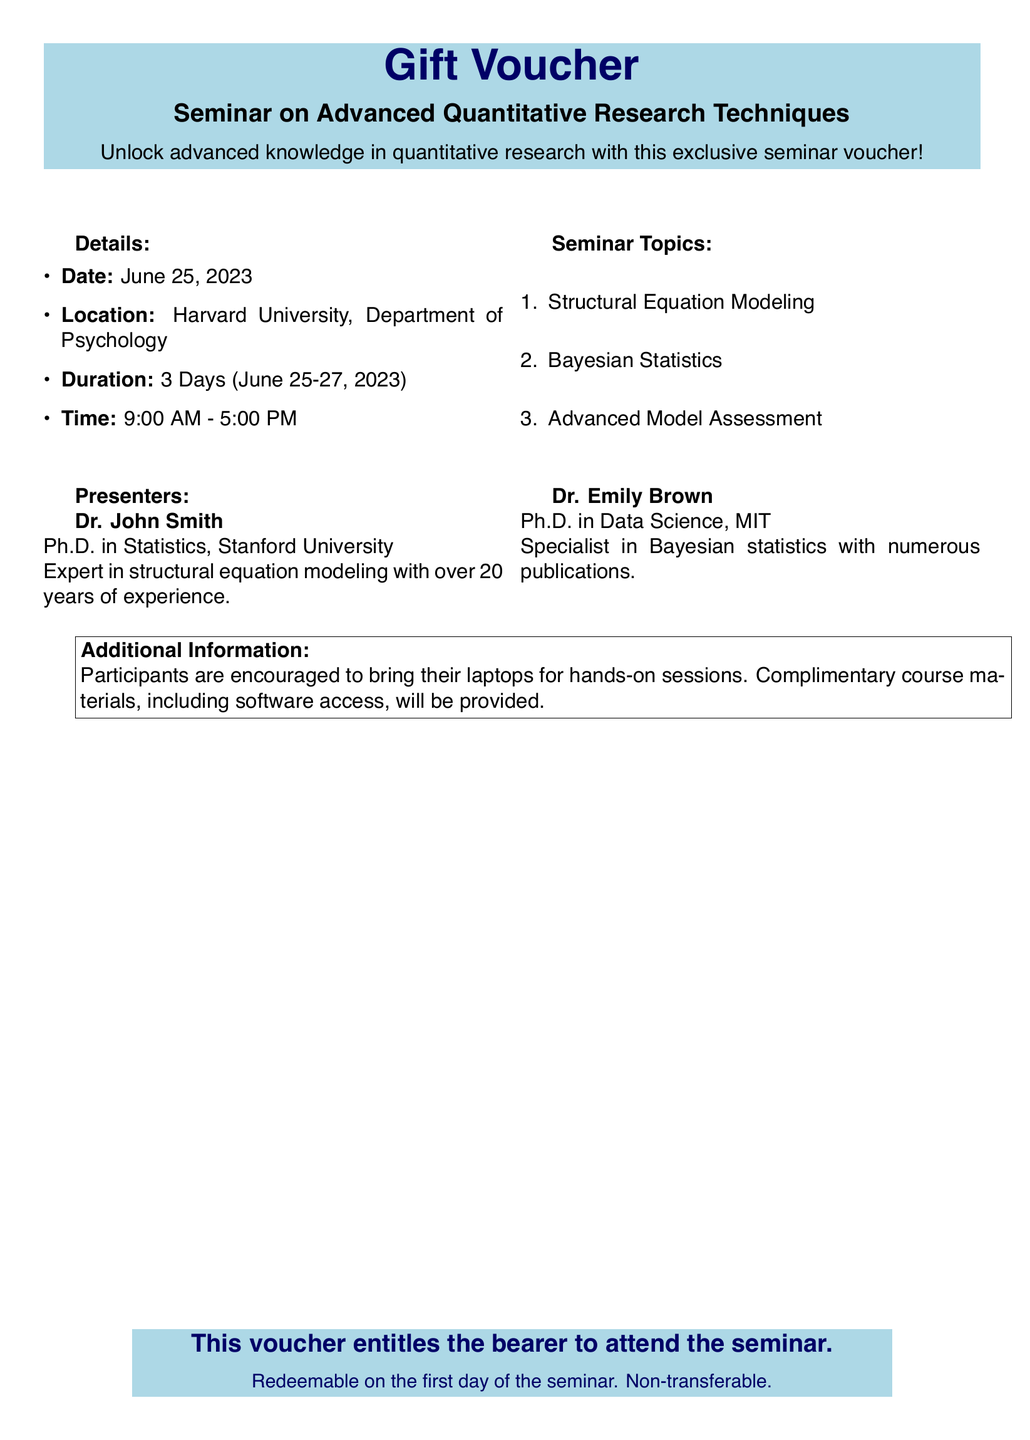What is the date of the seminar? The date of the seminar is explicitly stated in the details section of the document.
Answer: June 25, 2023 Where is the seminar located? The location of the seminar is mentioned directly in the details section of the document.
Answer: Harvard University, Department of Psychology How many days does the seminar last? The duration of the seminar is provided in the details section, indicating the total number of days.
Answer: 3 Days Who is one of the presenters? The document lists the presenters with their names in the presenters section, allowing us to identify one.
Answer: Dr. John Smith What is one of the seminar topics? The seminar topics are listed in a numbered format in the document, allowing for easy identification.
Answer: Structural Equation Modeling What are participants encouraged to bring? The additional information section states what participants should bring for the seminar.
Answer: Laptops Is the voucher transferable? The terms provided at the bottom of the voucher clarify the status of transferability.
Answer: Non-transferable What time does the seminar start? The time is specified in the details section of the document, giving a clear start time.
Answer: 9:00 AM 